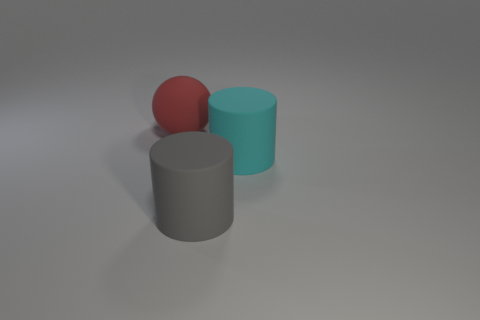Subtract all cyan cylinders. Subtract all brown spheres. How many cylinders are left? 1 Add 1 big yellow matte blocks. How many objects exist? 4 Subtract all balls. How many objects are left? 2 Subtract all big gray matte blocks. Subtract all large matte balls. How many objects are left? 2 Add 1 cyan cylinders. How many cyan cylinders are left? 2 Add 2 gray matte cylinders. How many gray matte cylinders exist? 3 Subtract 0 gray spheres. How many objects are left? 3 